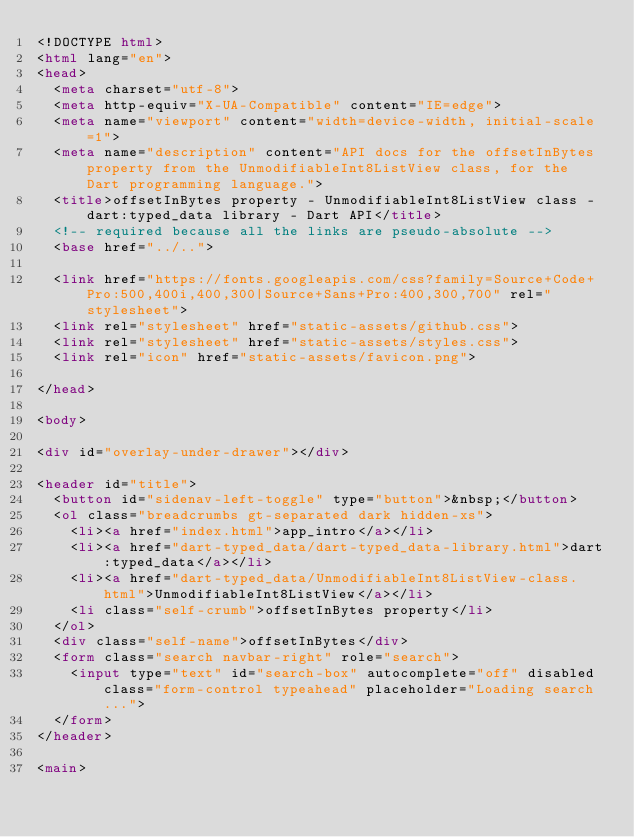Convert code to text. <code><loc_0><loc_0><loc_500><loc_500><_HTML_><!DOCTYPE html>
<html lang="en">
<head>
  <meta charset="utf-8">
  <meta http-equiv="X-UA-Compatible" content="IE=edge">
  <meta name="viewport" content="width=device-width, initial-scale=1">
  <meta name="description" content="API docs for the offsetInBytes property from the UnmodifiableInt8ListView class, for the Dart programming language.">
  <title>offsetInBytes property - UnmodifiableInt8ListView class - dart:typed_data library - Dart API</title>
  <!-- required because all the links are pseudo-absolute -->
  <base href="../..">

  <link href="https://fonts.googleapis.com/css?family=Source+Code+Pro:500,400i,400,300|Source+Sans+Pro:400,300,700" rel="stylesheet">
  <link rel="stylesheet" href="static-assets/github.css">
  <link rel="stylesheet" href="static-assets/styles.css">
  <link rel="icon" href="static-assets/favicon.png">
  
</head>

<body>

<div id="overlay-under-drawer"></div>

<header id="title">
  <button id="sidenav-left-toggle" type="button">&nbsp;</button>
  <ol class="breadcrumbs gt-separated dark hidden-xs">
    <li><a href="index.html">app_intro</a></li>
    <li><a href="dart-typed_data/dart-typed_data-library.html">dart:typed_data</a></li>
    <li><a href="dart-typed_data/UnmodifiableInt8ListView-class.html">UnmodifiableInt8ListView</a></li>
    <li class="self-crumb">offsetInBytes property</li>
  </ol>
  <div class="self-name">offsetInBytes</div>
  <form class="search navbar-right" role="search">
    <input type="text" id="search-box" autocomplete="off" disabled class="form-control typeahead" placeholder="Loading search...">
  </form>
</header>

<main>
</code> 